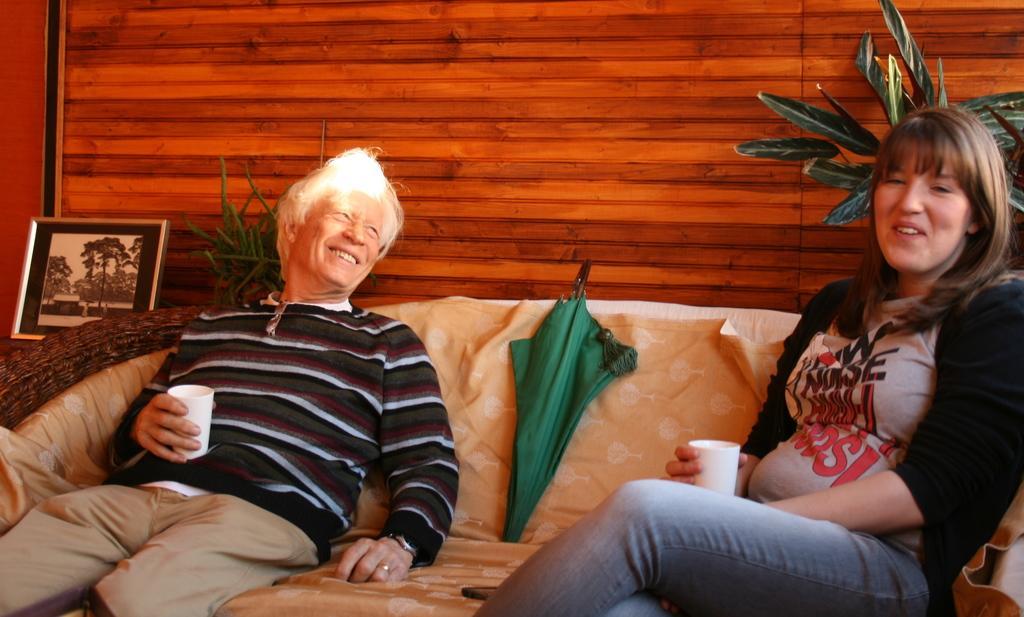Describe this image in one or two sentences. In this picture we can see two persons are sitting on a couch, they are smiling and holding glasses, we can see an umbrella in the middle, on the left side we can see a photo frame, in the background there is a wall and two plants. 